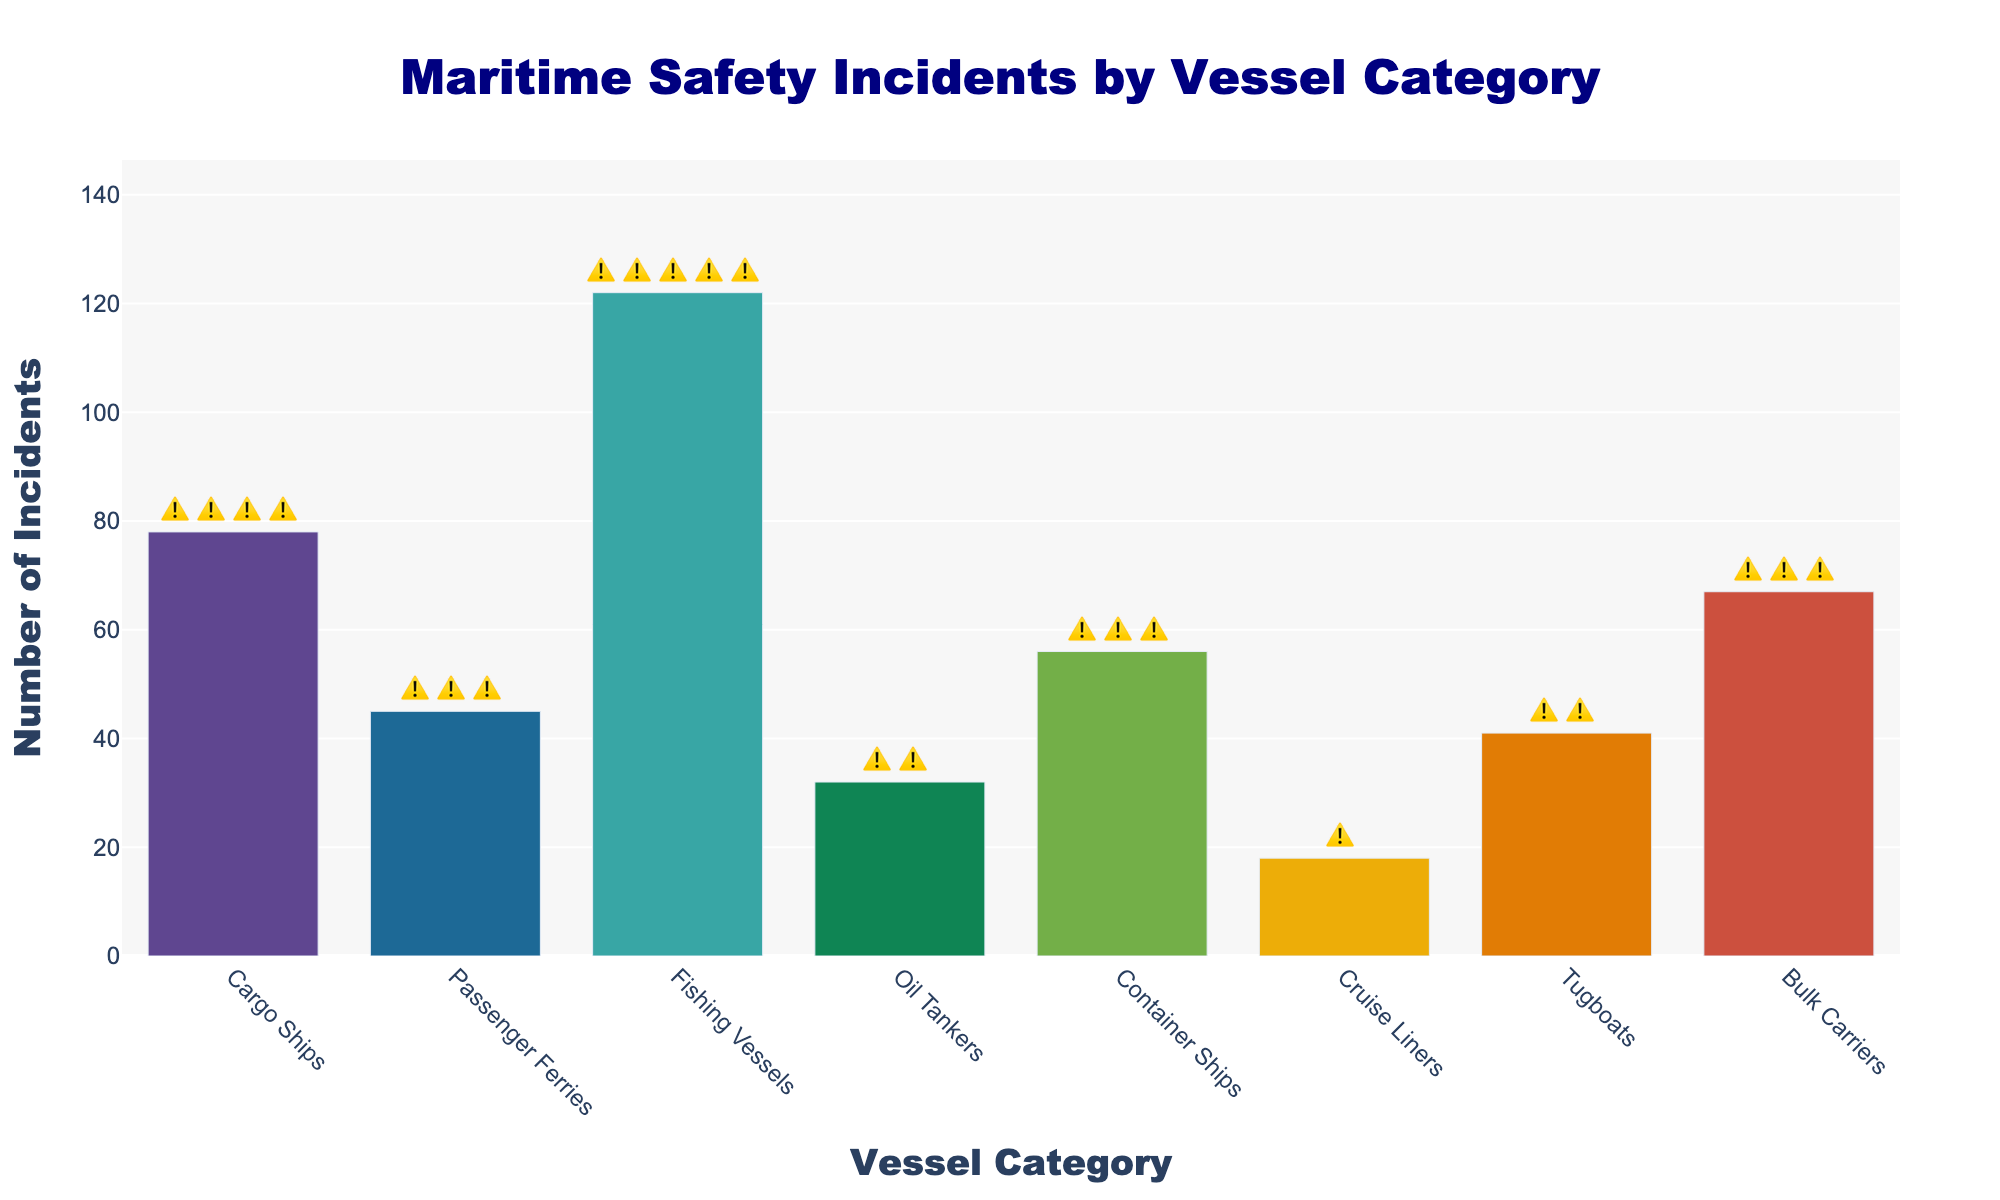What is the title of the figure? The title of a chart is usually located at the top and it clearly indicates what the data represents. Read the title of the chart to find out.
Answer: Maritime Safety Incidents by Vessel Category How many incidents were reported for Fishing Vessels? Look for the bar representing Fishing Vessels and check the numerical value on the y-axis. The text number above the bar represents the incidents.
Answer: 122 Which vessel category had the fewest incidents? Compare the heights of all the bars and find the shortest one. The category under the shortest bar indicates the vessel with the fewest incidents.
Answer: Cruise Liners How many warning signs ⚠️ are there for Oil Tankers? Identify the bar for Oil Tankers and look at the number of warning signs (⚠️) displayed above it. Count the warning signs shown.
Answer: 2 What is the total number of incidents for Cargo Ships and Container Ships combined? Find the incidents for Cargo Ships and Container Ships individually and add them. Cargo Ships have 78 incidents and Container Ships have 56 incidents. 78 + 56 = 134.
Answer: 134 Is the number of incidents for Passenger Ferries higher than Tugboats? Compare the heights of the bars for Passenger Ferries and Tugboats. The bar with greater height represents the higher value.
Answer: Yes What is the average number of incidents across all vessel categories? Sum the number of incidents for all vessel categories and divide by the number of categories. (78 + 45 + 122 + 32 + 56 + 18 + 41 + 67) / 8 = 459 / 8 = 57.375.
Answer: 57.375 How many vessel categories have more than 50 incidents? Count the number of bars with heights representing incidents greater than 50. Identify these bars: (Cargo Ships, Fishing Vessels, Container Ships, Bulk Carriers).
Answer: 4 Which vessel category has the second highest number of incidents? Order the bars from highest to lowest based on their value, and find the one that is second in line. The highest is Fishing Vessels (122), and the second highest is Cargo Ships (78).
Answer: Cargo Ships 